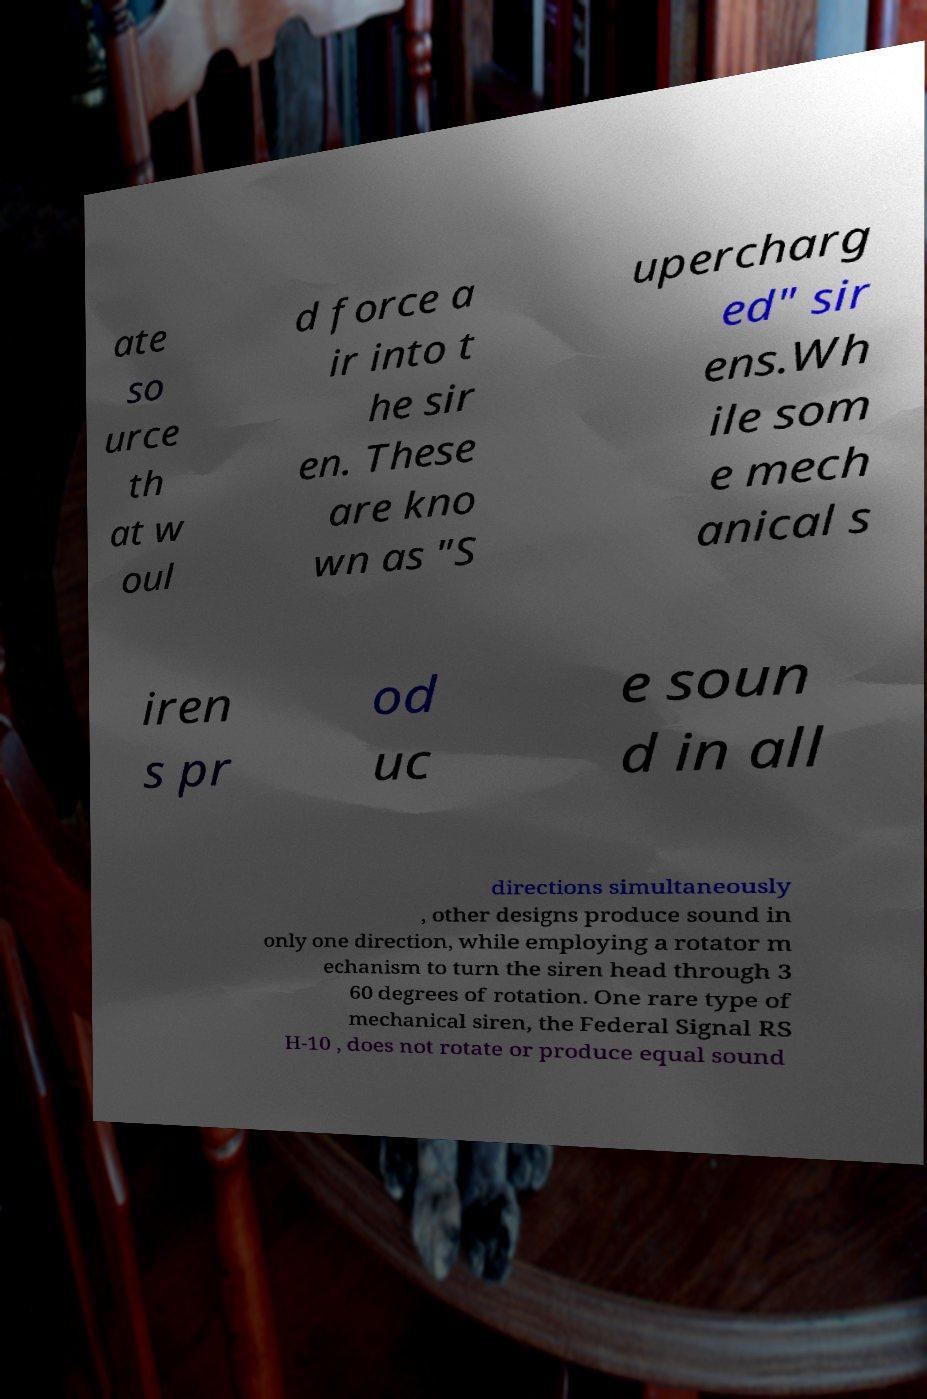Could you extract and type out the text from this image? ate so urce th at w oul d force a ir into t he sir en. These are kno wn as "S upercharg ed" sir ens.Wh ile som e mech anical s iren s pr od uc e soun d in all directions simultaneously , other designs produce sound in only one direction, while employing a rotator m echanism to turn the siren head through 3 60 degrees of rotation. One rare type of mechanical siren, the Federal Signal RS H-10 , does not rotate or produce equal sound 